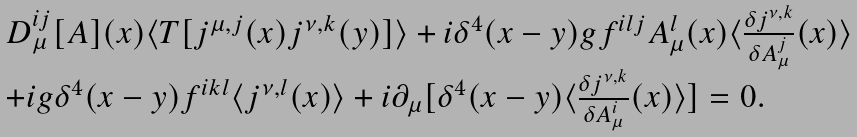<formula> <loc_0><loc_0><loc_500><loc_500>\begin{array} { l } D _ { \mu } ^ { i j } [ A ] ( x ) \langle T [ j ^ { \mu , j } ( x ) j ^ { \nu , k } ( y ) ] \rangle + i \delta ^ { 4 } ( x - y ) g f ^ { i l j } A _ { \mu } ^ { l } ( x ) \langle \frac { \delta j ^ { \nu , k } } { \delta A _ { \mu } ^ { j } } ( x ) \rangle \\ + i g \delta ^ { 4 } ( x - y ) f ^ { i k l } \langle j ^ { \nu , l } ( x ) \rangle + i \partial _ { \mu } [ \delta ^ { 4 } ( x - y ) \langle \frac { \delta j ^ { \nu , k } } { \delta A _ { \mu } ^ { i } } ( x ) \rangle ] = 0 . \end{array}</formula> 